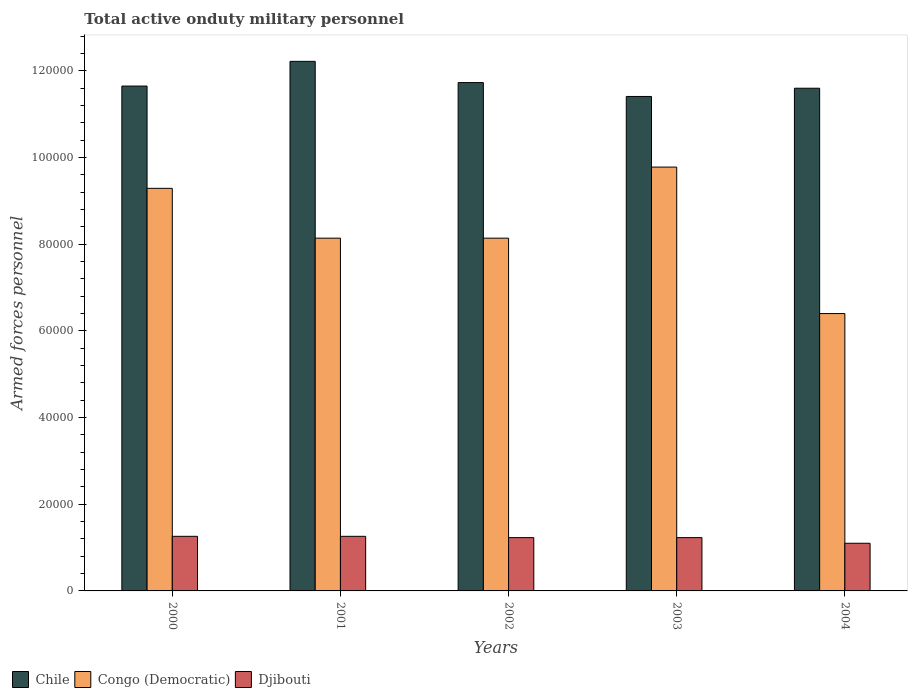Are the number of bars per tick equal to the number of legend labels?
Provide a short and direct response. Yes. Are the number of bars on each tick of the X-axis equal?
Give a very brief answer. Yes. How many bars are there on the 4th tick from the right?
Your answer should be compact. 3. What is the label of the 4th group of bars from the left?
Offer a very short reply. 2003. What is the number of armed forces personnel in Chile in 2003?
Your answer should be compact. 1.14e+05. Across all years, what is the maximum number of armed forces personnel in Chile?
Provide a succinct answer. 1.22e+05. Across all years, what is the minimum number of armed forces personnel in Chile?
Your answer should be compact. 1.14e+05. In which year was the number of armed forces personnel in Congo (Democratic) maximum?
Make the answer very short. 2003. In which year was the number of armed forces personnel in Chile minimum?
Ensure brevity in your answer.  2003. What is the total number of armed forces personnel in Djibouti in the graph?
Ensure brevity in your answer.  6.08e+04. What is the difference between the number of armed forces personnel in Chile in 2000 and that in 2002?
Keep it short and to the point. -800. What is the difference between the number of armed forces personnel in Djibouti in 2001 and the number of armed forces personnel in Chile in 2004?
Keep it short and to the point. -1.03e+05. What is the average number of armed forces personnel in Chile per year?
Keep it short and to the point. 1.17e+05. In the year 2004, what is the difference between the number of armed forces personnel in Congo (Democratic) and number of armed forces personnel in Djibouti?
Provide a short and direct response. 5.30e+04. In how many years, is the number of armed forces personnel in Chile greater than 40000?
Your response must be concise. 5. What is the ratio of the number of armed forces personnel in Djibouti in 2001 to that in 2003?
Offer a very short reply. 1.02. What is the difference between the highest and the second highest number of armed forces personnel in Chile?
Keep it short and to the point. 4900. What is the difference between the highest and the lowest number of armed forces personnel in Djibouti?
Your response must be concise. 1600. Is the sum of the number of armed forces personnel in Congo (Democratic) in 2002 and 2004 greater than the maximum number of armed forces personnel in Chile across all years?
Make the answer very short. Yes. What does the 3rd bar from the left in 2002 represents?
Ensure brevity in your answer.  Djibouti. Is it the case that in every year, the sum of the number of armed forces personnel in Djibouti and number of armed forces personnel in Congo (Democratic) is greater than the number of armed forces personnel in Chile?
Provide a short and direct response. No. How many years are there in the graph?
Provide a short and direct response. 5. What is the difference between two consecutive major ticks on the Y-axis?
Your answer should be compact. 2.00e+04. Does the graph contain any zero values?
Your response must be concise. No. What is the title of the graph?
Provide a succinct answer. Total active onduty military personnel. Does "Seychelles" appear as one of the legend labels in the graph?
Your answer should be compact. No. What is the label or title of the X-axis?
Your answer should be compact. Years. What is the label or title of the Y-axis?
Provide a succinct answer. Armed forces personnel. What is the Armed forces personnel of Chile in 2000?
Your response must be concise. 1.16e+05. What is the Armed forces personnel of Congo (Democratic) in 2000?
Make the answer very short. 9.29e+04. What is the Armed forces personnel of Djibouti in 2000?
Give a very brief answer. 1.26e+04. What is the Armed forces personnel in Chile in 2001?
Provide a short and direct response. 1.22e+05. What is the Armed forces personnel of Congo (Democratic) in 2001?
Offer a very short reply. 8.14e+04. What is the Armed forces personnel in Djibouti in 2001?
Provide a short and direct response. 1.26e+04. What is the Armed forces personnel of Chile in 2002?
Your answer should be very brief. 1.17e+05. What is the Armed forces personnel of Congo (Democratic) in 2002?
Keep it short and to the point. 8.14e+04. What is the Armed forces personnel of Djibouti in 2002?
Your answer should be very brief. 1.23e+04. What is the Armed forces personnel of Chile in 2003?
Provide a short and direct response. 1.14e+05. What is the Armed forces personnel of Congo (Democratic) in 2003?
Give a very brief answer. 9.78e+04. What is the Armed forces personnel of Djibouti in 2003?
Your answer should be very brief. 1.23e+04. What is the Armed forces personnel of Chile in 2004?
Your answer should be very brief. 1.16e+05. What is the Armed forces personnel in Congo (Democratic) in 2004?
Provide a short and direct response. 6.40e+04. What is the Armed forces personnel in Djibouti in 2004?
Ensure brevity in your answer.  1.10e+04. Across all years, what is the maximum Armed forces personnel of Chile?
Keep it short and to the point. 1.22e+05. Across all years, what is the maximum Armed forces personnel in Congo (Democratic)?
Ensure brevity in your answer.  9.78e+04. Across all years, what is the maximum Armed forces personnel of Djibouti?
Make the answer very short. 1.26e+04. Across all years, what is the minimum Armed forces personnel in Chile?
Make the answer very short. 1.14e+05. Across all years, what is the minimum Armed forces personnel in Congo (Democratic)?
Your answer should be very brief. 6.40e+04. Across all years, what is the minimum Armed forces personnel of Djibouti?
Offer a very short reply. 1.10e+04. What is the total Armed forces personnel of Chile in the graph?
Your answer should be compact. 5.86e+05. What is the total Armed forces personnel in Congo (Democratic) in the graph?
Your answer should be compact. 4.18e+05. What is the total Armed forces personnel in Djibouti in the graph?
Your answer should be compact. 6.08e+04. What is the difference between the Armed forces personnel of Chile in 2000 and that in 2001?
Offer a terse response. -5700. What is the difference between the Armed forces personnel in Congo (Democratic) in 2000 and that in 2001?
Your answer should be very brief. 1.15e+04. What is the difference between the Armed forces personnel in Chile in 2000 and that in 2002?
Offer a terse response. -800. What is the difference between the Armed forces personnel of Congo (Democratic) in 2000 and that in 2002?
Provide a short and direct response. 1.15e+04. What is the difference between the Armed forces personnel in Djibouti in 2000 and that in 2002?
Give a very brief answer. 300. What is the difference between the Armed forces personnel of Chile in 2000 and that in 2003?
Your answer should be compact. 2400. What is the difference between the Armed forces personnel of Congo (Democratic) in 2000 and that in 2003?
Offer a terse response. -4900. What is the difference between the Armed forces personnel of Djibouti in 2000 and that in 2003?
Your answer should be very brief. 300. What is the difference between the Armed forces personnel in Chile in 2000 and that in 2004?
Offer a very short reply. 500. What is the difference between the Armed forces personnel of Congo (Democratic) in 2000 and that in 2004?
Keep it short and to the point. 2.89e+04. What is the difference between the Armed forces personnel of Djibouti in 2000 and that in 2004?
Your answer should be compact. 1600. What is the difference between the Armed forces personnel of Chile in 2001 and that in 2002?
Your response must be concise. 4900. What is the difference between the Armed forces personnel of Djibouti in 2001 and that in 2002?
Provide a short and direct response. 300. What is the difference between the Armed forces personnel of Chile in 2001 and that in 2003?
Keep it short and to the point. 8100. What is the difference between the Armed forces personnel in Congo (Democratic) in 2001 and that in 2003?
Your response must be concise. -1.64e+04. What is the difference between the Armed forces personnel of Djibouti in 2001 and that in 2003?
Give a very brief answer. 300. What is the difference between the Armed forces personnel of Chile in 2001 and that in 2004?
Give a very brief answer. 6200. What is the difference between the Armed forces personnel of Congo (Democratic) in 2001 and that in 2004?
Offer a terse response. 1.74e+04. What is the difference between the Armed forces personnel of Djibouti in 2001 and that in 2004?
Make the answer very short. 1600. What is the difference between the Armed forces personnel in Chile in 2002 and that in 2003?
Provide a short and direct response. 3200. What is the difference between the Armed forces personnel in Congo (Democratic) in 2002 and that in 2003?
Your answer should be very brief. -1.64e+04. What is the difference between the Armed forces personnel in Djibouti in 2002 and that in 2003?
Offer a very short reply. 0. What is the difference between the Armed forces personnel of Chile in 2002 and that in 2004?
Your answer should be very brief. 1300. What is the difference between the Armed forces personnel in Congo (Democratic) in 2002 and that in 2004?
Make the answer very short. 1.74e+04. What is the difference between the Armed forces personnel in Djibouti in 2002 and that in 2004?
Make the answer very short. 1300. What is the difference between the Armed forces personnel in Chile in 2003 and that in 2004?
Your response must be concise. -1900. What is the difference between the Armed forces personnel of Congo (Democratic) in 2003 and that in 2004?
Your answer should be very brief. 3.38e+04. What is the difference between the Armed forces personnel of Djibouti in 2003 and that in 2004?
Offer a terse response. 1300. What is the difference between the Armed forces personnel of Chile in 2000 and the Armed forces personnel of Congo (Democratic) in 2001?
Give a very brief answer. 3.51e+04. What is the difference between the Armed forces personnel in Chile in 2000 and the Armed forces personnel in Djibouti in 2001?
Your response must be concise. 1.04e+05. What is the difference between the Armed forces personnel in Congo (Democratic) in 2000 and the Armed forces personnel in Djibouti in 2001?
Ensure brevity in your answer.  8.03e+04. What is the difference between the Armed forces personnel in Chile in 2000 and the Armed forces personnel in Congo (Democratic) in 2002?
Make the answer very short. 3.51e+04. What is the difference between the Armed forces personnel in Chile in 2000 and the Armed forces personnel in Djibouti in 2002?
Your answer should be very brief. 1.04e+05. What is the difference between the Armed forces personnel in Congo (Democratic) in 2000 and the Armed forces personnel in Djibouti in 2002?
Offer a very short reply. 8.06e+04. What is the difference between the Armed forces personnel of Chile in 2000 and the Armed forces personnel of Congo (Democratic) in 2003?
Provide a short and direct response. 1.87e+04. What is the difference between the Armed forces personnel in Chile in 2000 and the Armed forces personnel in Djibouti in 2003?
Make the answer very short. 1.04e+05. What is the difference between the Armed forces personnel of Congo (Democratic) in 2000 and the Armed forces personnel of Djibouti in 2003?
Give a very brief answer. 8.06e+04. What is the difference between the Armed forces personnel in Chile in 2000 and the Armed forces personnel in Congo (Democratic) in 2004?
Make the answer very short. 5.25e+04. What is the difference between the Armed forces personnel in Chile in 2000 and the Armed forces personnel in Djibouti in 2004?
Provide a succinct answer. 1.06e+05. What is the difference between the Armed forces personnel in Congo (Democratic) in 2000 and the Armed forces personnel in Djibouti in 2004?
Offer a very short reply. 8.19e+04. What is the difference between the Armed forces personnel in Chile in 2001 and the Armed forces personnel in Congo (Democratic) in 2002?
Offer a terse response. 4.08e+04. What is the difference between the Armed forces personnel in Chile in 2001 and the Armed forces personnel in Djibouti in 2002?
Offer a terse response. 1.10e+05. What is the difference between the Armed forces personnel in Congo (Democratic) in 2001 and the Armed forces personnel in Djibouti in 2002?
Give a very brief answer. 6.91e+04. What is the difference between the Armed forces personnel in Chile in 2001 and the Armed forces personnel in Congo (Democratic) in 2003?
Provide a short and direct response. 2.44e+04. What is the difference between the Armed forces personnel in Chile in 2001 and the Armed forces personnel in Djibouti in 2003?
Ensure brevity in your answer.  1.10e+05. What is the difference between the Armed forces personnel of Congo (Democratic) in 2001 and the Armed forces personnel of Djibouti in 2003?
Your answer should be very brief. 6.91e+04. What is the difference between the Armed forces personnel in Chile in 2001 and the Armed forces personnel in Congo (Democratic) in 2004?
Provide a succinct answer. 5.82e+04. What is the difference between the Armed forces personnel in Chile in 2001 and the Armed forces personnel in Djibouti in 2004?
Offer a terse response. 1.11e+05. What is the difference between the Armed forces personnel in Congo (Democratic) in 2001 and the Armed forces personnel in Djibouti in 2004?
Offer a terse response. 7.04e+04. What is the difference between the Armed forces personnel of Chile in 2002 and the Armed forces personnel of Congo (Democratic) in 2003?
Provide a short and direct response. 1.95e+04. What is the difference between the Armed forces personnel in Chile in 2002 and the Armed forces personnel in Djibouti in 2003?
Your response must be concise. 1.05e+05. What is the difference between the Armed forces personnel of Congo (Democratic) in 2002 and the Armed forces personnel of Djibouti in 2003?
Offer a very short reply. 6.91e+04. What is the difference between the Armed forces personnel in Chile in 2002 and the Armed forces personnel in Congo (Democratic) in 2004?
Your answer should be compact. 5.33e+04. What is the difference between the Armed forces personnel in Chile in 2002 and the Armed forces personnel in Djibouti in 2004?
Your response must be concise. 1.06e+05. What is the difference between the Armed forces personnel of Congo (Democratic) in 2002 and the Armed forces personnel of Djibouti in 2004?
Ensure brevity in your answer.  7.04e+04. What is the difference between the Armed forces personnel in Chile in 2003 and the Armed forces personnel in Congo (Democratic) in 2004?
Your answer should be very brief. 5.01e+04. What is the difference between the Armed forces personnel in Chile in 2003 and the Armed forces personnel in Djibouti in 2004?
Your answer should be compact. 1.03e+05. What is the difference between the Armed forces personnel in Congo (Democratic) in 2003 and the Armed forces personnel in Djibouti in 2004?
Your answer should be very brief. 8.68e+04. What is the average Armed forces personnel of Chile per year?
Give a very brief answer. 1.17e+05. What is the average Armed forces personnel of Congo (Democratic) per year?
Offer a terse response. 8.35e+04. What is the average Armed forces personnel in Djibouti per year?
Make the answer very short. 1.22e+04. In the year 2000, what is the difference between the Armed forces personnel in Chile and Armed forces personnel in Congo (Democratic)?
Make the answer very short. 2.36e+04. In the year 2000, what is the difference between the Armed forces personnel in Chile and Armed forces personnel in Djibouti?
Ensure brevity in your answer.  1.04e+05. In the year 2000, what is the difference between the Armed forces personnel of Congo (Democratic) and Armed forces personnel of Djibouti?
Provide a short and direct response. 8.03e+04. In the year 2001, what is the difference between the Armed forces personnel in Chile and Armed forces personnel in Congo (Democratic)?
Keep it short and to the point. 4.08e+04. In the year 2001, what is the difference between the Armed forces personnel of Chile and Armed forces personnel of Djibouti?
Give a very brief answer. 1.10e+05. In the year 2001, what is the difference between the Armed forces personnel of Congo (Democratic) and Armed forces personnel of Djibouti?
Make the answer very short. 6.88e+04. In the year 2002, what is the difference between the Armed forces personnel of Chile and Armed forces personnel of Congo (Democratic)?
Your answer should be compact. 3.59e+04. In the year 2002, what is the difference between the Armed forces personnel of Chile and Armed forces personnel of Djibouti?
Provide a short and direct response. 1.05e+05. In the year 2002, what is the difference between the Armed forces personnel of Congo (Democratic) and Armed forces personnel of Djibouti?
Your answer should be compact. 6.91e+04. In the year 2003, what is the difference between the Armed forces personnel in Chile and Armed forces personnel in Congo (Democratic)?
Keep it short and to the point. 1.63e+04. In the year 2003, what is the difference between the Armed forces personnel in Chile and Armed forces personnel in Djibouti?
Make the answer very short. 1.02e+05. In the year 2003, what is the difference between the Armed forces personnel of Congo (Democratic) and Armed forces personnel of Djibouti?
Give a very brief answer. 8.55e+04. In the year 2004, what is the difference between the Armed forces personnel of Chile and Armed forces personnel of Congo (Democratic)?
Your answer should be very brief. 5.20e+04. In the year 2004, what is the difference between the Armed forces personnel in Chile and Armed forces personnel in Djibouti?
Give a very brief answer. 1.05e+05. In the year 2004, what is the difference between the Armed forces personnel in Congo (Democratic) and Armed forces personnel in Djibouti?
Make the answer very short. 5.30e+04. What is the ratio of the Armed forces personnel in Chile in 2000 to that in 2001?
Ensure brevity in your answer.  0.95. What is the ratio of the Armed forces personnel of Congo (Democratic) in 2000 to that in 2001?
Provide a short and direct response. 1.14. What is the ratio of the Armed forces personnel in Chile in 2000 to that in 2002?
Provide a short and direct response. 0.99. What is the ratio of the Armed forces personnel of Congo (Democratic) in 2000 to that in 2002?
Ensure brevity in your answer.  1.14. What is the ratio of the Armed forces personnel in Djibouti in 2000 to that in 2002?
Your response must be concise. 1.02. What is the ratio of the Armed forces personnel of Chile in 2000 to that in 2003?
Ensure brevity in your answer.  1.02. What is the ratio of the Armed forces personnel in Congo (Democratic) in 2000 to that in 2003?
Give a very brief answer. 0.95. What is the ratio of the Armed forces personnel in Djibouti in 2000 to that in 2003?
Your answer should be compact. 1.02. What is the ratio of the Armed forces personnel of Chile in 2000 to that in 2004?
Provide a short and direct response. 1. What is the ratio of the Armed forces personnel of Congo (Democratic) in 2000 to that in 2004?
Your response must be concise. 1.45. What is the ratio of the Armed forces personnel of Djibouti in 2000 to that in 2004?
Offer a very short reply. 1.15. What is the ratio of the Armed forces personnel in Chile in 2001 to that in 2002?
Your answer should be compact. 1.04. What is the ratio of the Armed forces personnel of Djibouti in 2001 to that in 2002?
Your answer should be very brief. 1.02. What is the ratio of the Armed forces personnel in Chile in 2001 to that in 2003?
Offer a very short reply. 1.07. What is the ratio of the Armed forces personnel of Congo (Democratic) in 2001 to that in 2003?
Ensure brevity in your answer.  0.83. What is the ratio of the Armed forces personnel of Djibouti in 2001 to that in 2003?
Give a very brief answer. 1.02. What is the ratio of the Armed forces personnel in Chile in 2001 to that in 2004?
Offer a very short reply. 1.05. What is the ratio of the Armed forces personnel of Congo (Democratic) in 2001 to that in 2004?
Your answer should be very brief. 1.27. What is the ratio of the Armed forces personnel of Djibouti in 2001 to that in 2004?
Offer a very short reply. 1.15. What is the ratio of the Armed forces personnel in Chile in 2002 to that in 2003?
Your answer should be very brief. 1.03. What is the ratio of the Armed forces personnel in Congo (Democratic) in 2002 to that in 2003?
Keep it short and to the point. 0.83. What is the ratio of the Armed forces personnel of Djibouti in 2002 to that in 2003?
Give a very brief answer. 1. What is the ratio of the Armed forces personnel of Chile in 2002 to that in 2004?
Make the answer very short. 1.01. What is the ratio of the Armed forces personnel of Congo (Democratic) in 2002 to that in 2004?
Your response must be concise. 1.27. What is the ratio of the Armed forces personnel in Djibouti in 2002 to that in 2004?
Provide a short and direct response. 1.12. What is the ratio of the Armed forces personnel of Chile in 2003 to that in 2004?
Provide a short and direct response. 0.98. What is the ratio of the Armed forces personnel in Congo (Democratic) in 2003 to that in 2004?
Ensure brevity in your answer.  1.53. What is the ratio of the Armed forces personnel of Djibouti in 2003 to that in 2004?
Offer a very short reply. 1.12. What is the difference between the highest and the second highest Armed forces personnel of Chile?
Give a very brief answer. 4900. What is the difference between the highest and the second highest Armed forces personnel in Congo (Democratic)?
Keep it short and to the point. 4900. What is the difference between the highest and the lowest Armed forces personnel in Chile?
Your answer should be compact. 8100. What is the difference between the highest and the lowest Armed forces personnel of Congo (Democratic)?
Provide a succinct answer. 3.38e+04. What is the difference between the highest and the lowest Armed forces personnel in Djibouti?
Give a very brief answer. 1600. 